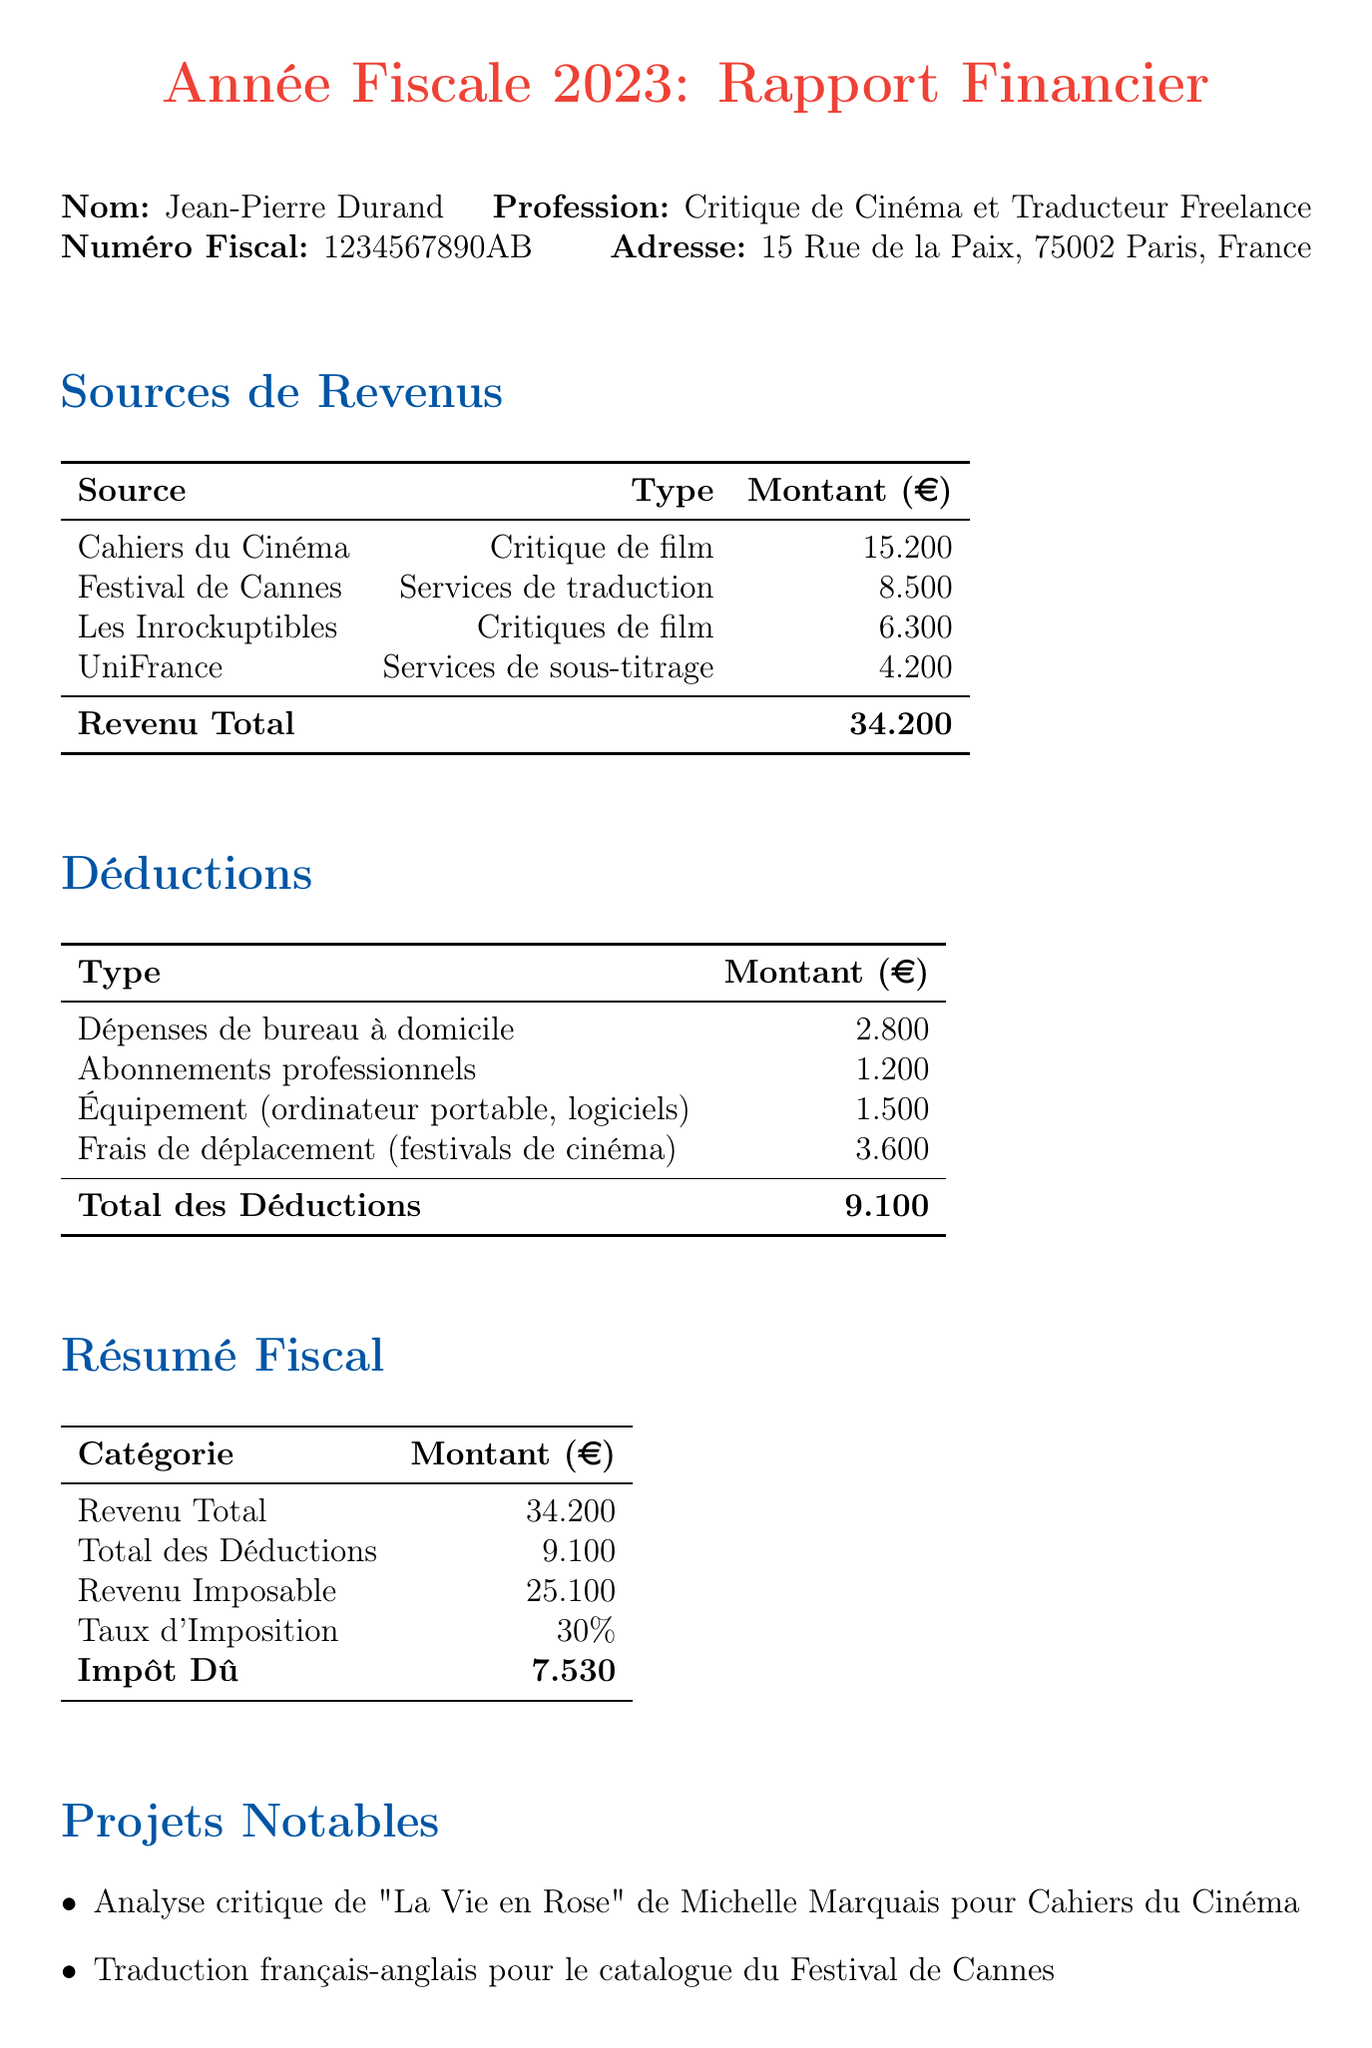What is the name of the freelancer? The name of the freelancer is found in the personal information section of the document.
Answer: Jean-Pierre Durand What is the total income reported? Total income is summarized in the financial report as the sum of all income sources mentioned.
Answer: 34,200 What amount is listed for travel expenses? Travel expenses are one of the deductions listed in the report, specifying the related costs.
Answer: 3,600 What is the tax owed for the year? The tax owed is calculated based on the taxable income and the tax rate, which is detailed in the summary section.
Answer: 7,530 How many notable projects are listed? The number of notable projects can be gathered from the list provided in the report's notable projects section.
Answer: 3 What type of event was attended for professional development? The event is specified in the professional development section of the document.
Answer: Seminar on Digital Film Criticism What is the total amount for deductions? Total deductions are found in the deductions table, which summarizes all deductible amounts.
Answer: 9,100 What is the tax rate applied? The tax rate is specified in the summary of the financial report.
Answer: 30% What was the income source for the largest amount? The source of the largest amount of income is highlighted in the income sources section of the document.
Answer: Cahiers du Cinéma 